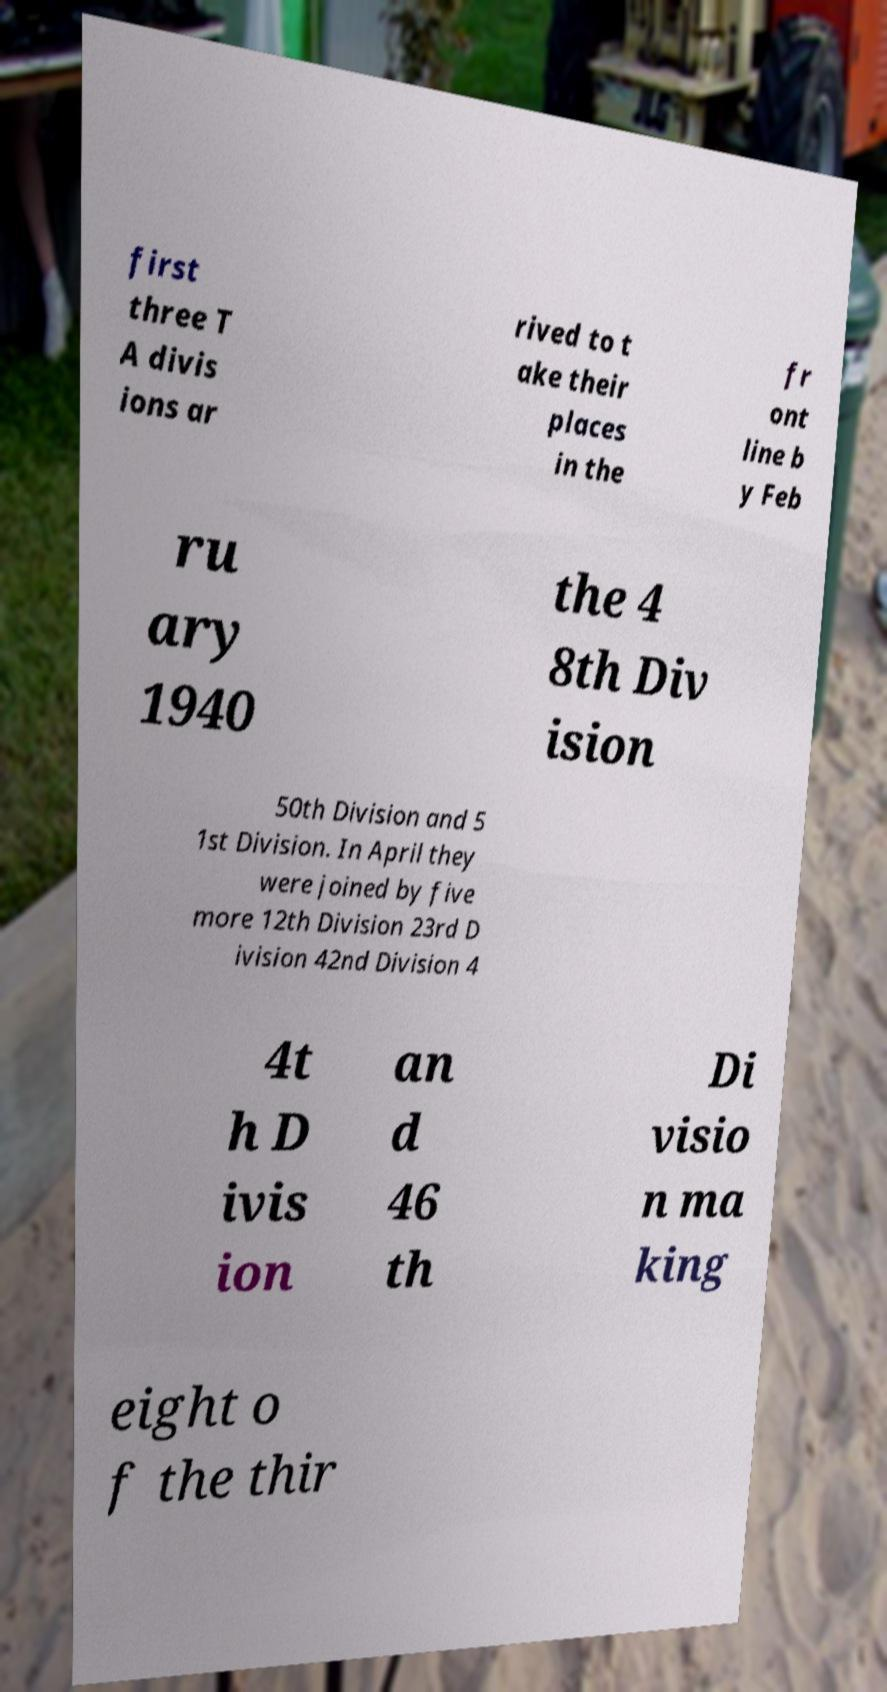Could you extract and type out the text from this image? first three T A divis ions ar rived to t ake their places in the fr ont line b y Feb ru ary 1940 the 4 8th Div ision 50th Division and 5 1st Division. In April they were joined by five more 12th Division 23rd D ivision 42nd Division 4 4t h D ivis ion an d 46 th Di visio n ma king eight o f the thir 